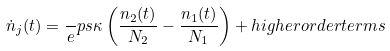Convert formula to latex. <formula><loc_0><loc_0><loc_500><loc_500>\dot { n } _ { j } ( t ) = \frac { \ } { e } p s { \kappa } \left ( \frac { n _ { 2 } ( t ) } { N _ { 2 } } - \frac { n _ { 1 } ( t ) } { N _ { 1 } } \right ) + h i g h e r o r d e r t e r m s</formula> 